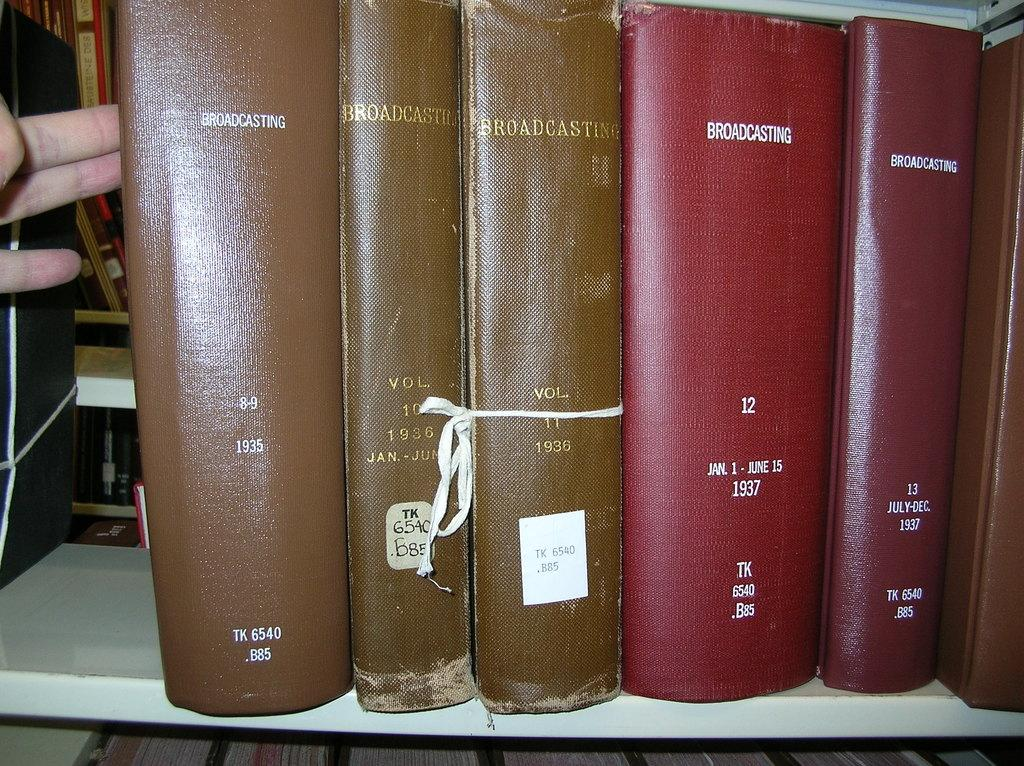<image>
Relay a brief, clear account of the picture shown. A collection of broadcasting books from 1935 to 1937. 